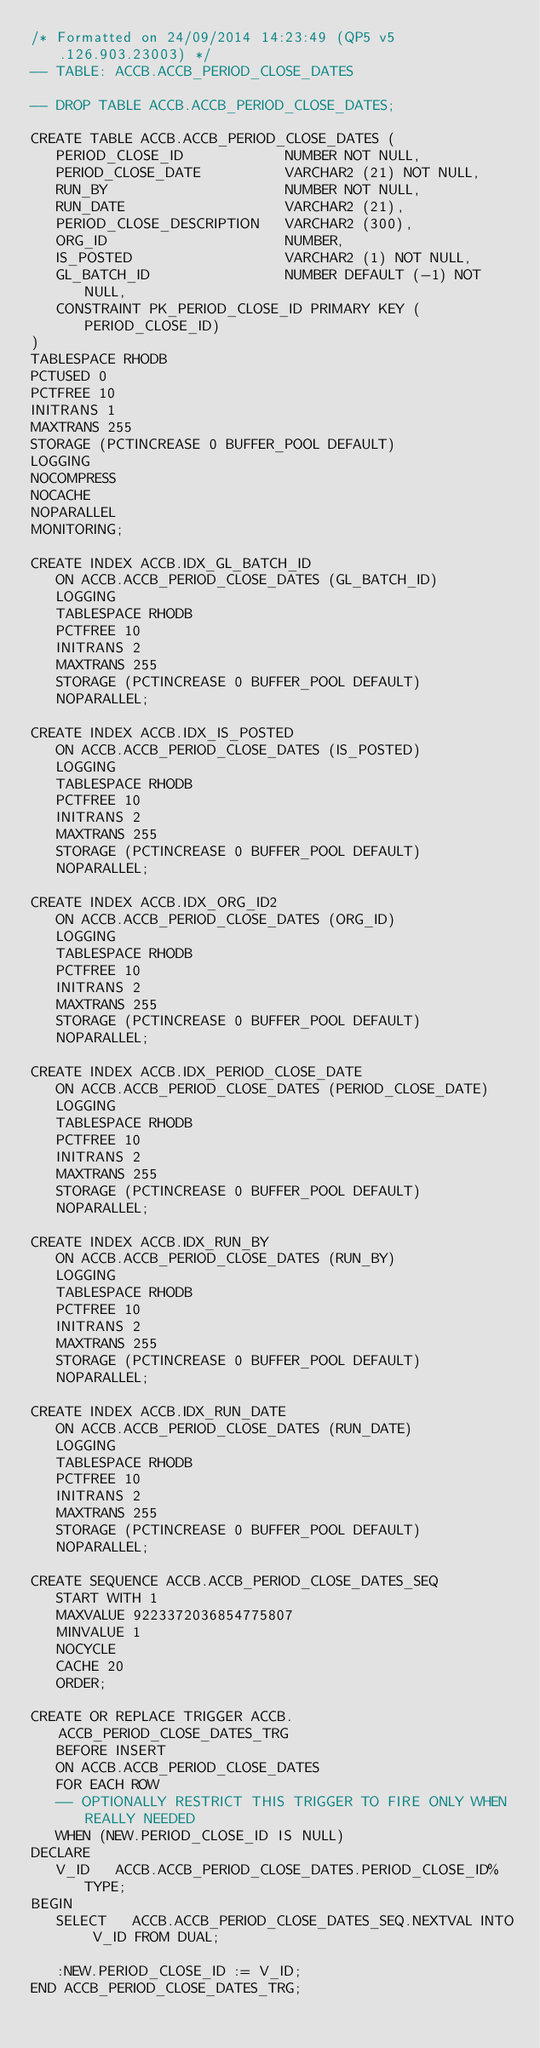<code> <loc_0><loc_0><loc_500><loc_500><_SQL_>/* Formatted on 24/09/2014 14:23:49 (QP5 v5.126.903.23003) */
-- TABLE: ACCB.ACCB_PERIOD_CLOSE_DATES

-- DROP TABLE ACCB.ACCB_PERIOD_CLOSE_DATES;

CREATE TABLE ACCB.ACCB_PERIOD_CLOSE_DATES (
   PERIOD_CLOSE_ID            NUMBER NOT NULL,
   PERIOD_CLOSE_DATE          VARCHAR2 (21) NOT NULL,
   RUN_BY                     NUMBER NOT NULL,
   RUN_DATE                   VARCHAR2 (21),
   PERIOD_CLOSE_DESCRIPTION   VARCHAR2 (300),
   ORG_ID                     NUMBER,
   IS_POSTED                  VARCHAR2 (1) NOT NULL,
   GL_BATCH_ID                NUMBER DEFAULT (-1) NOT NULL,
   CONSTRAINT PK_PERIOD_CLOSE_ID PRIMARY KEY (PERIOD_CLOSE_ID)
)
TABLESPACE RHODB
PCTUSED 0
PCTFREE 10
INITRANS 1
MAXTRANS 255
STORAGE (PCTINCREASE 0 BUFFER_POOL DEFAULT)
LOGGING
NOCOMPRESS
NOCACHE
NOPARALLEL
MONITORING;

CREATE INDEX ACCB.IDX_GL_BATCH_ID
   ON ACCB.ACCB_PERIOD_CLOSE_DATES (GL_BATCH_ID)
   LOGGING
   TABLESPACE RHODB
   PCTFREE 10
   INITRANS 2
   MAXTRANS 255
   STORAGE (PCTINCREASE 0 BUFFER_POOL DEFAULT)
   NOPARALLEL;

CREATE INDEX ACCB.IDX_IS_POSTED
   ON ACCB.ACCB_PERIOD_CLOSE_DATES (IS_POSTED)
   LOGGING
   TABLESPACE RHODB
   PCTFREE 10
   INITRANS 2
   MAXTRANS 255
   STORAGE (PCTINCREASE 0 BUFFER_POOL DEFAULT)
   NOPARALLEL;

CREATE INDEX ACCB.IDX_ORG_ID2
   ON ACCB.ACCB_PERIOD_CLOSE_DATES (ORG_ID)
   LOGGING
   TABLESPACE RHODB
   PCTFREE 10
   INITRANS 2
   MAXTRANS 255
   STORAGE (PCTINCREASE 0 BUFFER_POOL DEFAULT)
   NOPARALLEL;

CREATE INDEX ACCB.IDX_PERIOD_CLOSE_DATE
   ON ACCB.ACCB_PERIOD_CLOSE_DATES (PERIOD_CLOSE_DATE)
   LOGGING
   TABLESPACE RHODB
   PCTFREE 10
   INITRANS 2
   MAXTRANS 255
   STORAGE (PCTINCREASE 0 BUFFER_POOL DEFAULT)
   NOPARALLEL;

CREATE INDEX ACCB.IDX_RUN_BY
   ON ACCB.ACCB_PERIOD_CLOSE_DATES (RUN_BY)
   LOGGING
   TABLESPACE RHODB
   PCTFREE 10
   INITRANS 2
   MAXTRANS 255
   STORAGE (PCTINCREASE 0 BUFFER_POOL DEFAULT)
   NOPARALLEL;

CREATE INDEX ACCB.IDX_RUN_DATE
   ON ACCB.ACCB_PERIOD_CLOSE_DATES (RUN_DATE)
   LOGGING
   TABLESPACE RHODB
   PCTFREE 10
   INITRANS 2
   MAXTRANS 255
   STORAGE (PCTINCREASE 0 BUFFER_POOL DEFAULT)
   NOPARALLEL;

CREATE SEQUENCE ACCB.ACCB_PERIOD_CLOSE_DATES_SEQ
   START WITH 1
   MAXVALUE 9223372036854775807
   MINVALUE 1
   NOCYCLE
   CACHE 20
   ORDER;

CREATE OR REPLACE TRIGGER ACCB.ACCB_PERIOD_CLOSE_DATES_TRG
   BEFORE INSERT
   ON ACCB.ACCB_PERIOD_CLOSE_DATES
   FOR EACH ROW
   -- OPTIONALLY RESTRICT THIS TRIGGER TO FIRE ONLY WHEN REALLY NEEDED
   WHEN (NEW.PERIOD_CLOSE_ID IS NULL)
DECLARE
   V_ID   ACCB.ACCB_PERIOD_CLOSE_DATES.PERIOD_CLOSE_ID%TYPE;
BEGIN
   SELECT   ACCB.ACCB_PERIOD_CLOSE_DATES_SEQ.NEXTVAL INTO V_ID FROM DUAL;

   :NEW.PERIOD_CLOSE_ID := V_ID;
END ACCB_PERIOD_CLOSE_DATES_TRG;</code> 